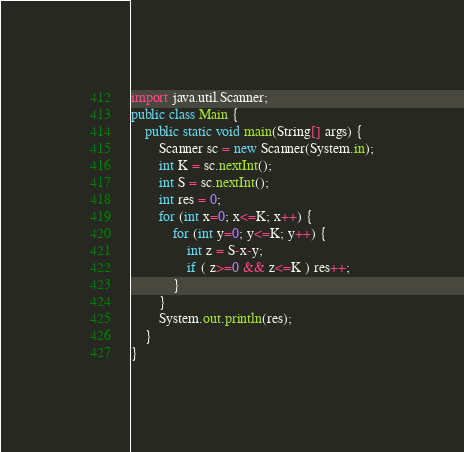<code> <loc_0><loc_0><loc_500><loc_500><_Java_>import java.util.Scanner;
public class Main {
	public static void main(String[] args) {
		Scanner sc = new Scanner(System.in);
		int K = sc.nextInt();
		int S = sc.nextInt();
		int res = 0;
		for (int x=0; x<=K; x++) {
			for (int y=0; y<=K; y++) {
				int z = S-x-y;
				if ( z>=0 && z<=K ) res++;
			}			
		}
		System.out.println(res);
	}
}
</code> 